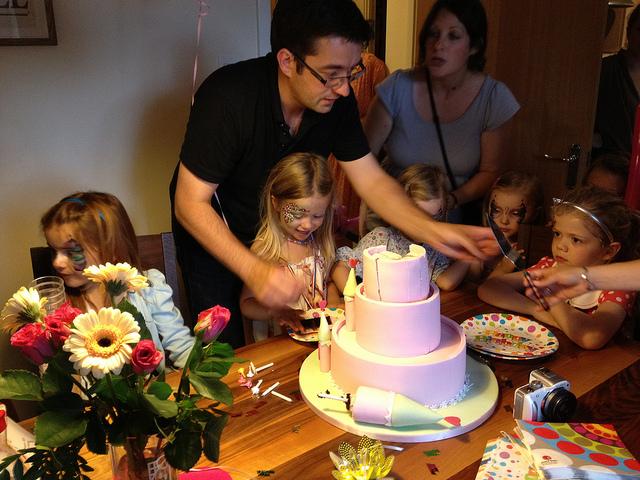How many kids in the picture?
Concise answer only. 6. What design was the cake made into?
Be succinct. Castle. Are the flowers real?
Keep it brief. No. 